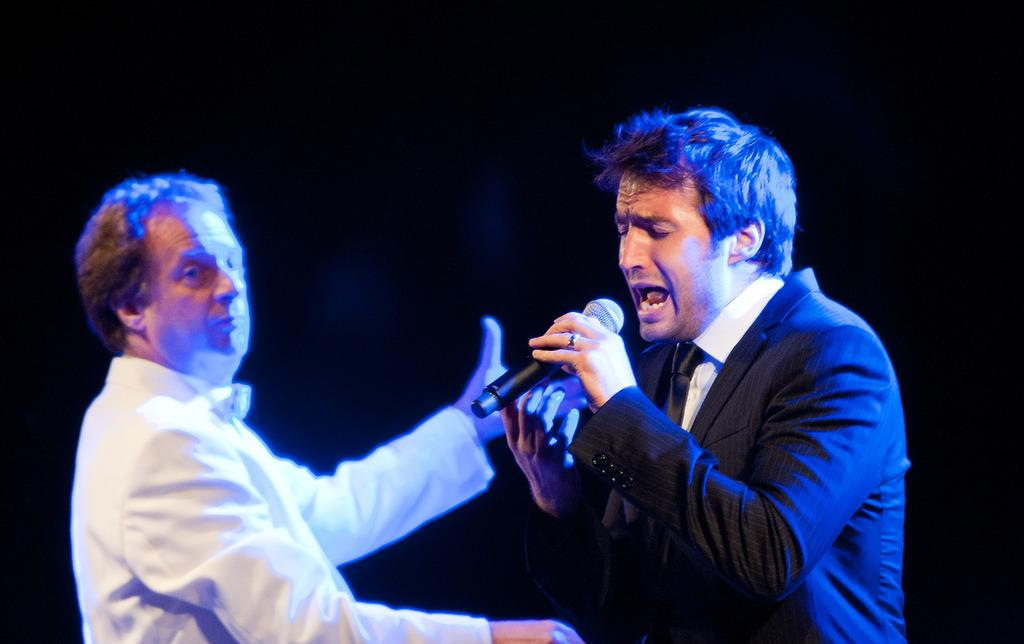What is the person in the image holding? The person in the image is holding a microphone. Can you describe the attire of the person holding the microphone? The person holding the microphone is wearing a blazer and a tie. What can be seen on the left side of the image? There is another person on the left side of the image. What is the person on the left side wearing? The person on the left side is wearing a white top. What is the color of the background in the image? The background of the image is black. What type of iron is being used by the person on the right side of the image? There is no iron present in the image, and there is no person on the right side of the image. 